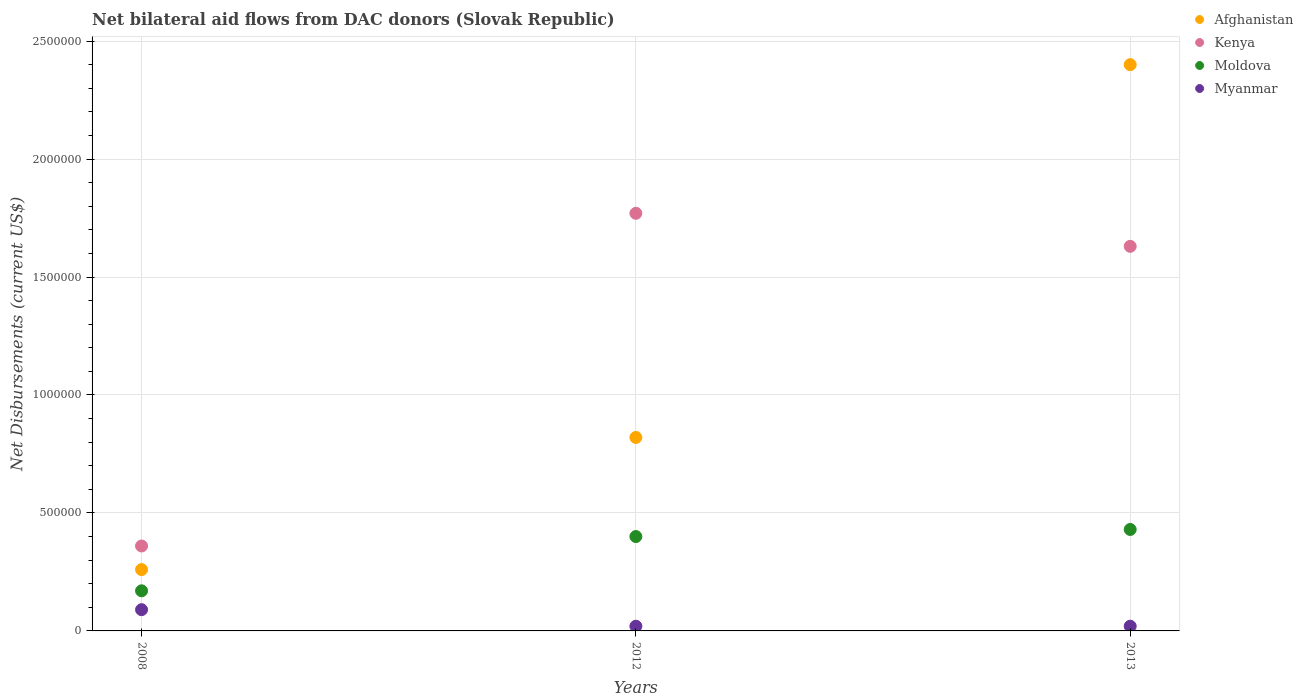How many different coloured dotlines are there?
Ensure brevity in your answer.  4. Across all years, what is the maximum net bilateral aid flows in Kenya?
Offer a terse response. 1.77e+06. Across all years, what is the minimum net bilateral aid flows in Afghanistan?
Your response must be concise. 2.60e+05. In which year was the net bilateral aid flows in Myanmar minimum?
Make the answer very short. 2012. What is the total net bilateral aid flows in Kenya in the graph?
Ensure brevity in your answer.  3.76e+06. What is the difference between the net bilateral aid flows in Afghanistan in 2008 and that in 2013?
Keep it short and to the point. -2.14e+06. What is the difference between the net bilateral aid flows in Moldova in 2008 and the net bilateral aid flows in Afghanistan in 2012?
Your answer should be compact. -6.50e+05. What is the average net bilateral aid flows in Moldova per year?
Your response must be concise. 3.33e+05. In the year 2013, what is the difference between the net bilateral aid flows in Moldova and net bilateral aid flows in Afghanistan?
Offer a very short reply. -1.97e+06. What is the ratio of the net bilateral aid flows in Kenya in 2008 to that in 2012?
Keep it short and to the point. 0.2. Is the sum of the net bilateral aid flows in Afghanistan in 2008 and 2012 greater than the maximum net bilateral aid flows in Myanmar across all years?
Give a very brief answer. Yes. Is it the case that in every year, the sum of the net bilateral aid flows in Afghanistan and net bilateral aid flows in Myanmar  is greater than the net bilateral aid flows in Kenya?
Offer a terse response. No. Is the net bilateral aid flows in Kenya strictly less than the net bilateral aid flows in Afghanistan over the years?
Keep it short and to the point. No. Does the graph contain any zero values?
Make the answer very short. No. Does the graph contain grids?
Your answer should be very brief. Yes. Where does the legend appear in the graph?
Your answer should be compact. Top right. How many legend labels are there?
Offer a terse response. 4. How are the legend labels stacked?
Make the answer very short. Vertical. What is the title of the graph?
Your response must be concise. Net bilateral aid flows from DAC donors (Slovak Republic). What is the label or title of the X-axis?
Provide a succinct answer. Years. What is the label or title of the Y-axis?
Your answer should be very brief. Net Disbursements (current US$). What is the Net Disbursements (current US$) of Myanmar in 2008?
Give a very brief answer. 9.00e+04. What is the Net Disbursements (current US$) of Afghanistan in 2012?
Make the answer very short. 8.20e+05. What is the Net Disbursements (current US$) of Kenya in 2012?
Give a very brief answer. 1.77e+06. What is the Net Disbursements (current US$) in Moldova in 2012?
Your answer should be compact. 4.00e+05. What is the Net Disbursements (current US$) in Myanmar in 2012?
Provide a succinct answer. 2.00e+04. What is the Net Disbursements (current US$) of Afghanistan in 2013?
Offer a very short reply. 2.40e+06. What is the Net Disbursements (current US$) in Kenya in 2013?
Ensure brevity in your answer.  1.63e+06. What is the Net Disbursements (current US$) in Myanmar in 2013?
Your answer should be compact. 2.00e+04. Across all years, what is the maximum Net Disbursements (current US$) of Afghanistan?
Your answer should be compact. 2.40e+06. Across all years, what is the maximum Net Disbursements (current US$) of Kenya?
Your answer should be very brief. 1.77e+06. Across all years, what is the minimum Net Disbursements (current US$) of Afghanistan?
Make the answer very short. 2.60e+05. Across all years, what is the minimum Net Disbursements (current US$) in Kenya?
Keep it short and to the point. 3.60e+05. Across all years, what is the minimum Net Disbursements (current US$) in Moldova?
Provide a succinct answer. 1.70e+05. What is the total Net Disbursements (current US$) of Afghanistan in the graph?
Provide a short and direct response. 3.48e+06. What is the total Net Disbursements (current US$) in Kenya in the graph?
Your response must be concise. 3.76e+06. What is the total Net Disbursements (current US$) in Moldova in the graph?
Offer a very short reply. 1.00e+06. What is the total Net Disbursements (current US$) of Myanmar in the graph?
Provide a short and direct response. 1.30e+05. What is the difference between the Net Disbursements (current US$) in Afghanistan in 2008 and that in 2012?
Keep it short and to the point. -5.60e+05. What is the difference between the Net Disbursements (current US$) of Kenya in 2008 and that in 2012?
Keep it short and to the point. -1.41e+06. What is the difference between the Net Disbursements (current US$) of Moldova in 2008 and that in 2012?
Provide a short and direct response. -2.30e+05. What is the difference between the Net Disbursements (current US$) of Afghanistan in 2008 and that in 2013?
Offer a very short reply. -2.14e+06. What is the difference between the Net Disbursements (current US$) in Kenya in 2008 and that in 2013?
Offer a terse response. -1.27e+06. What is the difference between the Net Disbursements (current US$) in Afghanistan in 2012 and that in 2013?
Give a very brief answer. -1.58e+06. What is the difference between the Net Disbursements (current US$) in Kenya in 2012 and that in 2013?
Provide a short and direct response. 1.40e+05. What is the difference between the Net Disbursements (current US$) in Moldova in 2012 and that in 2013?
Make the answer very short. -3.00e+04. What is the difference between the Net Disbursements (current US$) in Afghanistan in 2008 and the Net Disbursements (current US$) in Kenya in 2012?
Provide a succinct answer. -1.51e+06. What is the difference between the Net Disbursements (current US$) in Afghanistan in 2008 and the Net Disbursements (current US$) in Moldova in 2012?
Ensure brevity in your answer.  -1.40e+05. What is the difference between the Net Disbursements (current US$) in Afghanistan in 2008 and the Net Disbursements (current US$) in Myanmar in 2012?
Give a very brief answer. 2.40e+05. What is the difference between the Net Disbursements (current US$) of Afghanistan in 2008 and the Net Disbursements (current US$) of Kenya in 2013?
Keep it short and to the point. -1.37e+06. What is the difference between the Net Disbursements (current US$) of Afghanistan in 2008 and the Net Disbursements (current US$) of Moldova in 2013?
Offer a terse response. -1.70e+05. What is the difference between the Net Disbursements (current US$) in Moldova in 2008 and the Net Disbursements (current US$) in Myanmar in 2013?
Offer a very short reply. 1.50e+05. What is the difference between the Net Disbursements (current US$) in Afghanistan in 2012 and the Net Disbursements (current US$) in Kenya in 2013?
Offer a very short reply. -8.10e+05. What is the difference between the Net Disbursements (current US$) of Afghanistan in 2012 and the Net Disbursements (current US$) of Moldova in 2013?
Ensure brevity in your answer.  3.90e+05. What is the difference between the Net Disbursements (current US$) of Afghanistan in 2012 and the Net Disbursements (current US$) of Myanmar in 2013?
Your answer should be very brief. 8.00e+05. What is the difference between the Net Disbursements (current US$) of Kenya in 2012 and the Net Disbursements (current US$) of Moldova in 2013?
Your answer should be compact. 1.34e+06. What is the difference between the Net Disbursements (current US$) of Kenya in 2012 and the Net Disbursements (current US$) of Myanmar in 2013?
Your answer should be very brief. 1.75e+06. What is the average Net Disbursements (current US$) in Afghanistan per year?
Give a very brief answer. 1.16e+06. What is the average Net Disbursements (current US$) in Kenya per year?
Your answer should be very brief. 1.25e+06. What is the average Net Disbursements (current US$) in Moldova per year?
Offer a terse response. 3.33e+05. What is the average Net Disbursements (current US$) in Myanmar per year?
Provide a succinct answer. 4.33e+04. In the year 2008, what is the difference between the Net Disbursements (current US$) of Afghanistan and Net Disbursements (current US$) of Moldova?
Offer a terse response. 9.00e+04. In the year 2008, what is the difference between the Net Disbursements (current US$) in Afghanistan and Net Disbursements (current US$) in Myanmar?
Your answer should be very brief. 1.70e+05. In the year 2008, what is the difference between the Net Disbursements (current US$) in Moldova and Net Disbursements (current US$) in Myanmar?
Give a very brief answer. 8.00e+04. In the year 2012, what is the difference between the Net Disbursements (current US$) of Afghanistan and Net Disbursements (current US$) of Kenya?
Keep it short and to the point. -9.50e+05. In the year 2012, what is the difference between the Net Disbursements (current US$) of Afghanistan and Net Disbursements (current US$) of Myanmar?
Provide a succinct answer. 8.00e+05. In the year 2012, what is the difference between the Net Disbursements (current US$) of Kenya and Net Disbursements (current US$) of Moldova?
Provide a short and direct response. 1.37e+06. In the year 2012, what is the difference between the Net Disbursements (current US$) in Kenya and Net Disbursements (current US$) in Myanmar?
Provide a short and direct response. 1.75e+06. In the year 2013, what is the difference between the Net Disbursements (current US$) of Afghanistan and Net Disbursements (current US$) of Kenya?
Provide a succinct answer. 7.70e+05. In the year 2013, what is the difference between the Net Disbursements (current US$) of Afghanistan and Net Disbursements (current US$) of Moldova?
Offer a very short reply. 1.97e+06. In the year 2013, what is the difference between the Net Disbursements (current US$) of Afghanistan and Net Disbursements (current US$) of Myanmar?
Give a very brief answer. 2.38e+06. In the year 2013, what is the difference between the Net Disbursements (current US$) in Kenya and Net Disbursements (current US$) in Moldova?
Your answer should be very brief. 1.20e+06. In the year 2013, what is the difference between the Net Disbursements (current US$) in Kenya and Net Disbursements (current US$) in Myanmar?
Provide a succinct answer. 1.61e+06. What is the ratio of the Net Disbursements (current US$) in Afghanistan in 2008 to that in 2012?
Make the answer very short. 0.32. What is the ratio of the Net Disbursements (current US$) in Kenya in 2008 to that in 2012?
Your answer should be compact. 0.2. What is the ratio of the Net Disbursements (current US$) of Moldova in 2008 to that in 2012?
Your answer should be compact. 0.42. What is the ratio of the Net Disbursements (current US$) of Myanmar in 2008 to that in 2012?
Make the answer very short. 4.5. What is the ratio of the Net Disbursements (current US$) of Afghanistan in 2008 to that in 2013?
Your response must be concise. 0.11. What is the ratio of the Net Disbursements (current US$) in Kenya in 2008 to that in 2013?
Ensure brevity in your answer.  0.22. What is the ratio of the Net Disbursements (current US$) of Moldova in 2008 to that in 2013?
Provide a short and direct response. 0.4. What is the ratio of the Net Disbursements (current US$) of Afghanistan in 2012 to that in 2013?
Give a very brief answer. 0.34. What is the ratio of the Net Disbursements (current US$) of Kenya in 2012 to that in 2013?
Your answer should be compact. 1.09. What is the ratio of the Net Disbursements (current US$) of Moldova in 2012 to that in 2013?
Provide a short and direct response. 0.93. What is the difference between the highest and the second highest Net Disbursements (current US$) of Afghanistan?
Your response must be concise. 1.58e+06. What is the difference between the highest and the second highest Net Disbursements (current US$) of Kenya?
Ensure brevity in your answer.  1.40e+05. What is the difference between the highest and the second highest Net Disbursements (current US$) in Myanmar?
Provide a succinct answer. 7.00e+04. What is the difference between the highest and the lowest Net Disbursements (current US$) in Afghanistan?
Provide a succinct answer. 2.14e+06. What is the difference between the highest and the lowest Net Disbursements (current US$) in Kenya?
Offer a very short reply. 1.41e+06. What is the difference between the highest and the lowest Net Disbursements (current US$) in Moldova?
Make the answer very short. 2.60e+05. What is the difference between the highest and the lowest Net Disbursements (current US$) of Myanmar?
Offer a terse response. 7.00e+04. 